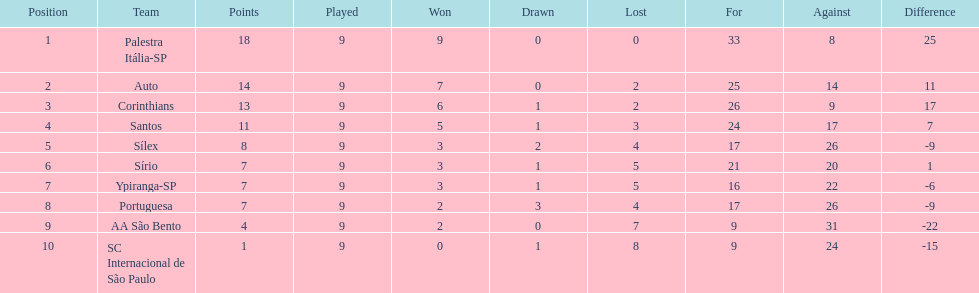In 1926 brazilian football, how many teams scored above 10 points in the season? 4. 